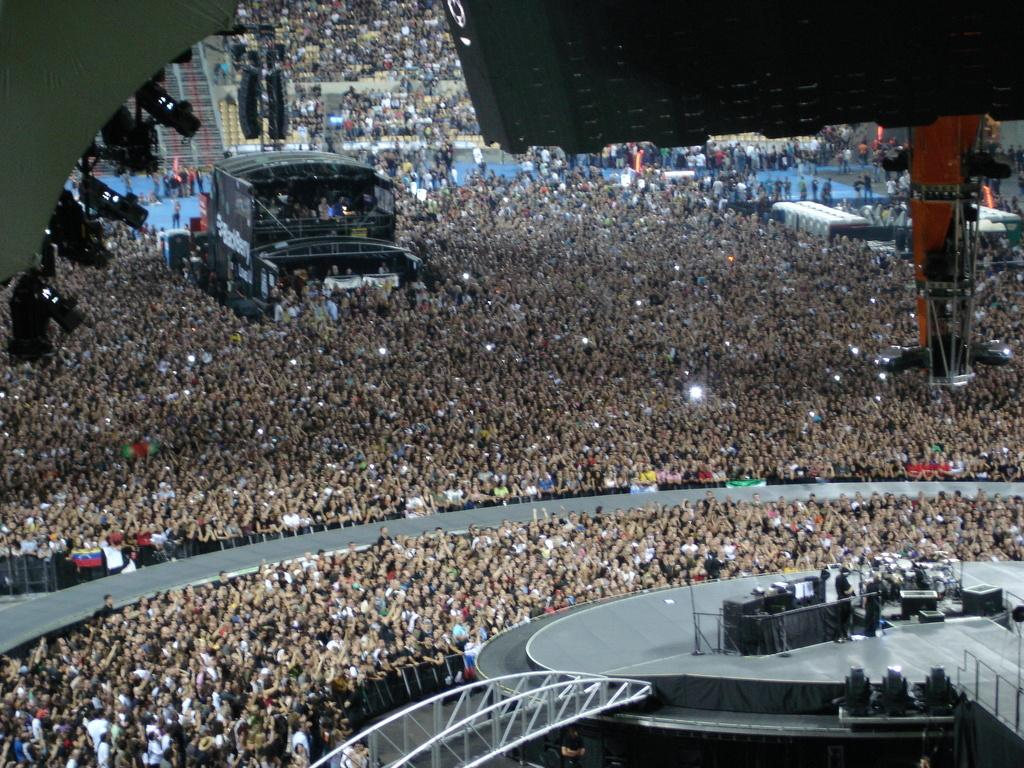What event might be taking place in the image? The image might be taken at a concert. What is located at the bottom of the image? There is a dais at the bottom of the image, and lights are also present there. What is happening on the dais? People are performing on the dais. Can you describe the lighting in the image? There are lights in the background of the image as well as at the bottom. What can be seen in the background of the image? There is a pillar and a crowd visible in the background. What type of celery is being used as a prop by the performers on the dais? There is no celery present in the image; it is not a prop used by the performers. What historical event is being commemorated by the sail in the background of the image? There is no sail present in the image, and no historical event is being commemorated. 